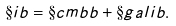<formula> <loc_0><loc_0><loc_500><loc_500>\S i b = \S c m b b + \S g a l i b .</formula> 